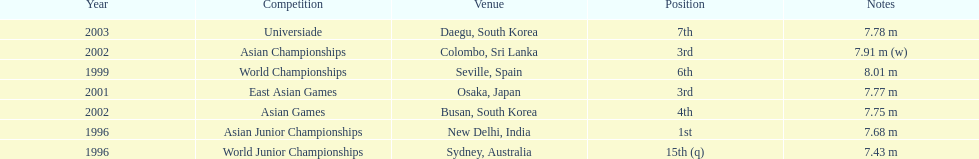What is the number of competitions that have been competed in? 7. 